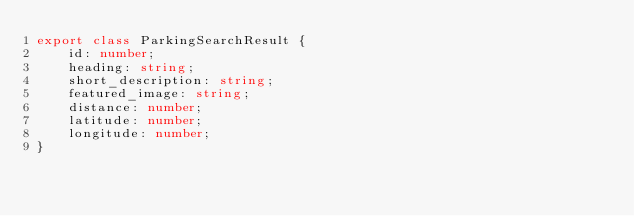<code> <loc_0><loc_0><loc_500><loc_500><_TypeScript_>export class ParkingSearchResult {
    id: number;
    heading: string;
    short_description: string;
    featured_image: string;
    distance: number;
    latitude: number;
    longitude: number;
}</code> 